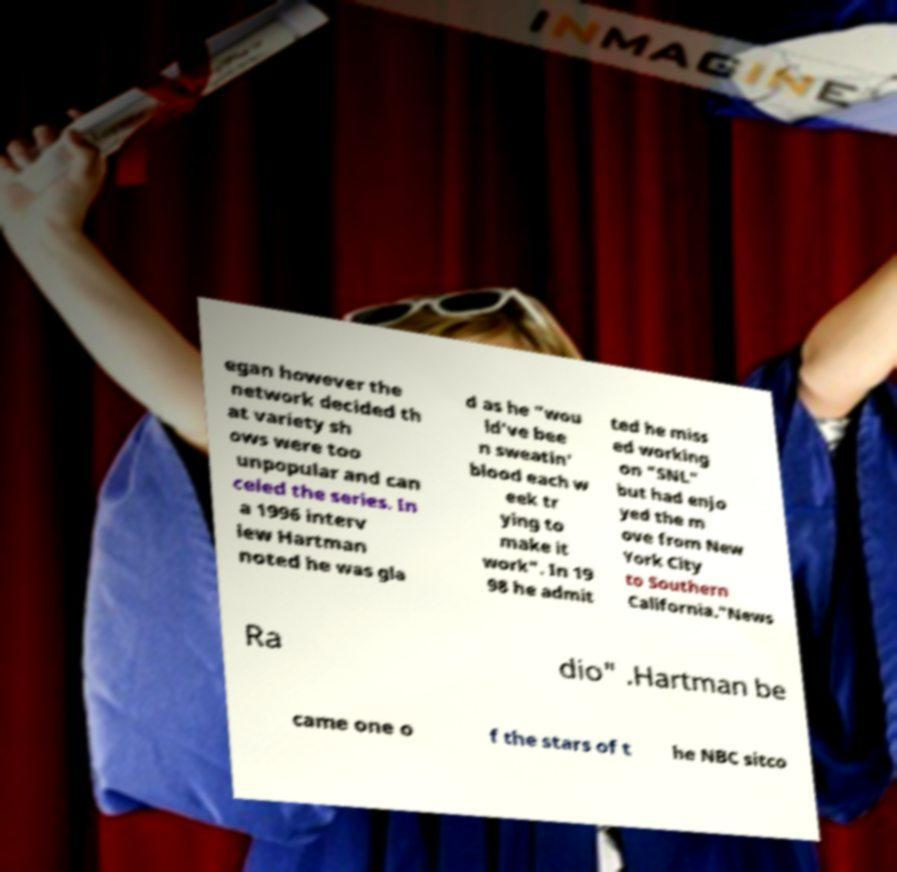What messages or text are displayed in this image? I need them in a readable, typed format. egan however the network decided th at variety sh ows were too unpopular and can celed the series. In a 1996 interv iew Hartman noted he was gla d as he "wou ld've bee n sweatin' blood each w eek tr ying to make it work". In 19 98 he admit ted he miss ed working on "SNL" but had enjo yed the m ove from New York City to Southern California."News Ra dio" .Hartman be came one o f the stars of t he NBC sitco 